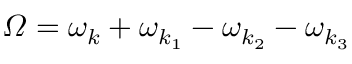<formula> <loc_0><loc_0><loc_500><loc_500>\varOmega = \omega _ { k } + \omega _ { k _ { 1 } } - \omega _ { k _ { 2 } } - \omega _ { k _ { 3 } }</formula> 